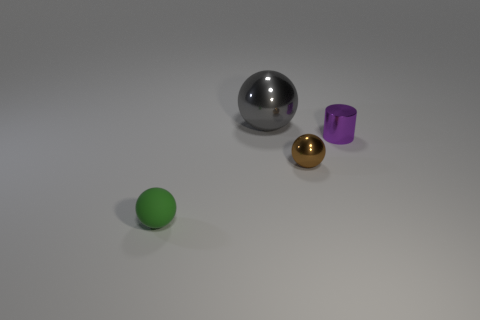What color is the small matte object?
Offer a very short reply. Green. What material is the gray object that is the same shape as the green rubber thing?
Offer a very short reply. Metal. Is there any other thing that is made of the same material as the small green ball?
Your answer should be very brief. No. There is a thing that is on the left side of the thing behind the small purple object; what shape is it?
Offer a terse response. Sphere. What shape is the other small object that is made of the same material as the small brown object?
Your response must be concise. Cylinder. How many other things are there of the same shape as the large thing?
Give a very brief answer. 2. There is a metal ball on the right side of the gray thing; is it the same size as the large metallic sphere?
Keep it short and to the point. No. Is the number of balls behind the rubber sphere greater than the number of matte objects?
Provide a succinct answer. Yes. There is a object that is on the right side of the brown sphere; what number of small green spheres are to the right of it?
Make the answer very short. 0. Are there fewer tiny green objects that are on the right side of the big metallic thing than tiny purple cylinders?
Your answer should be very brief. Yes. 